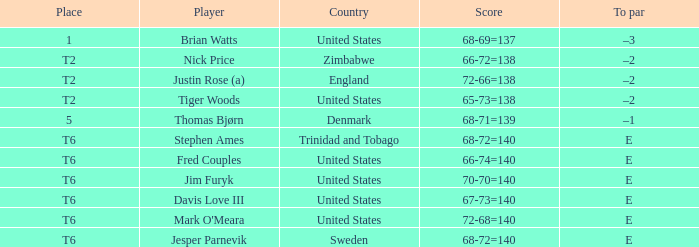What was the TO par for the player who scored 68-71=139? –1. 